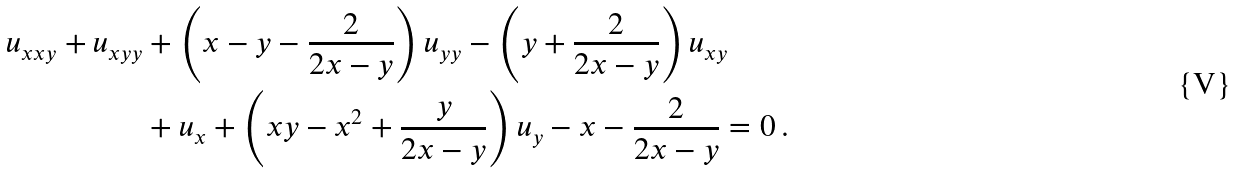<formula> <loc_0><loc_0><loc_500><loc_500>u _ { x x y } + u _ { x y y } & + \left ( x - y - \frac { 2 } { 2 x - y } \right ) u _ { y y } - \left ( y + \frac { 2 } { 2 x - y } \right ) u _ { x y } \\ & + u _ { x } + \left ( x y - x ^ { 2 } + \frac { y } { 2 x - y } \right ) u _ { y } - x - \frac { 2 } { 2 x - y } = 0 \, .</formula> 